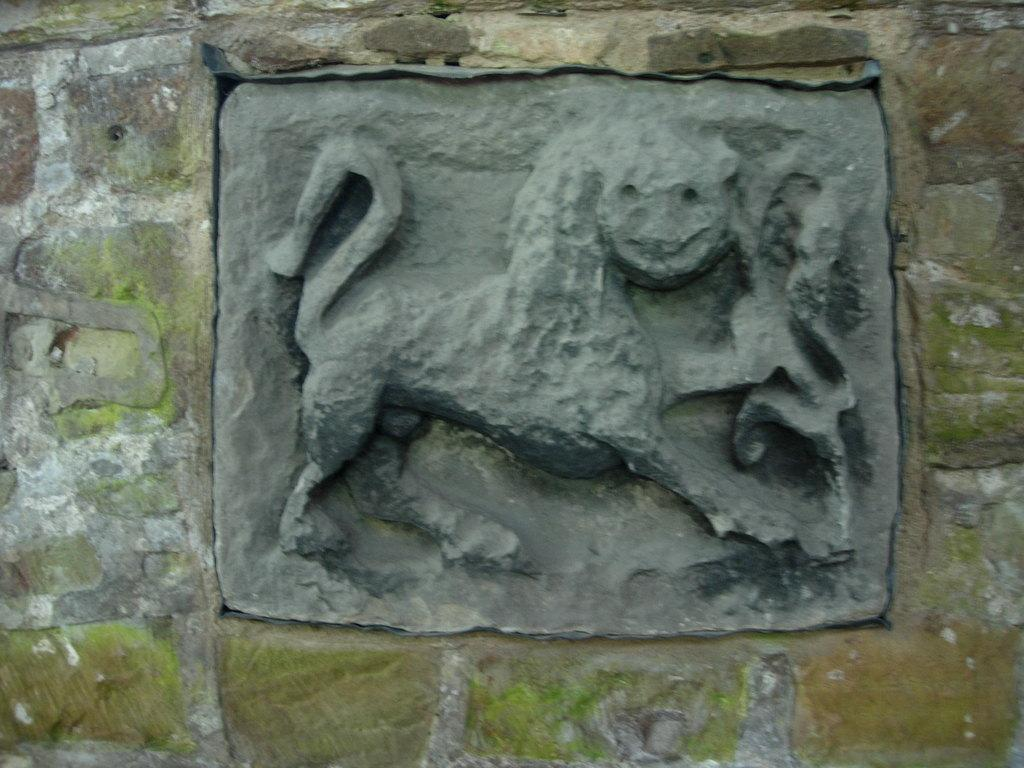What is the main subject of the image? There is a sculpture in the image. What material is the sculpture created on? The sculpture is created on a stone. Where is the sculpture located in relation to the wall? The sculpture is present in the middle of a wall. How many cherries are hanging from the sculpture in the image? There are no cherries present in the image; it features a sculpture on a stone. What type of wind can be seen blowing through the sculpture in the image? There is no wind, such as a zephyr, depicted in the image; it only shows a sculpture on a stone. 